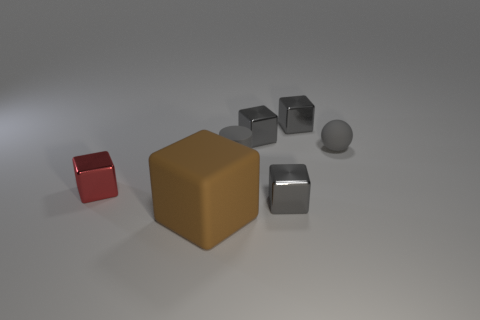How many gray blocks must be subtracted to get 1 gray blocks? 2 Subtract all large brown matte cubes. How many cubes are left? 4 Add 2 gray shiny blocks. How many objects exist? 9 Subtract 1 cylinders. How many cylinders are left? 0 Subtract all red blocks. How many blocks are left? 4 Subtract all cyan cylinders. How many gray blocks are left? 3 Subtract all cylinders. How many objects are left? 6 Subtract all purple cylinders. Subtract all purple cubes. How many cylinders are left? 1 Subtract all small gray matte balls. Subtract all big brown matte cubes. How many objects are left? 5 Add 6 big brown objects. How many big brown objects are left? 7 